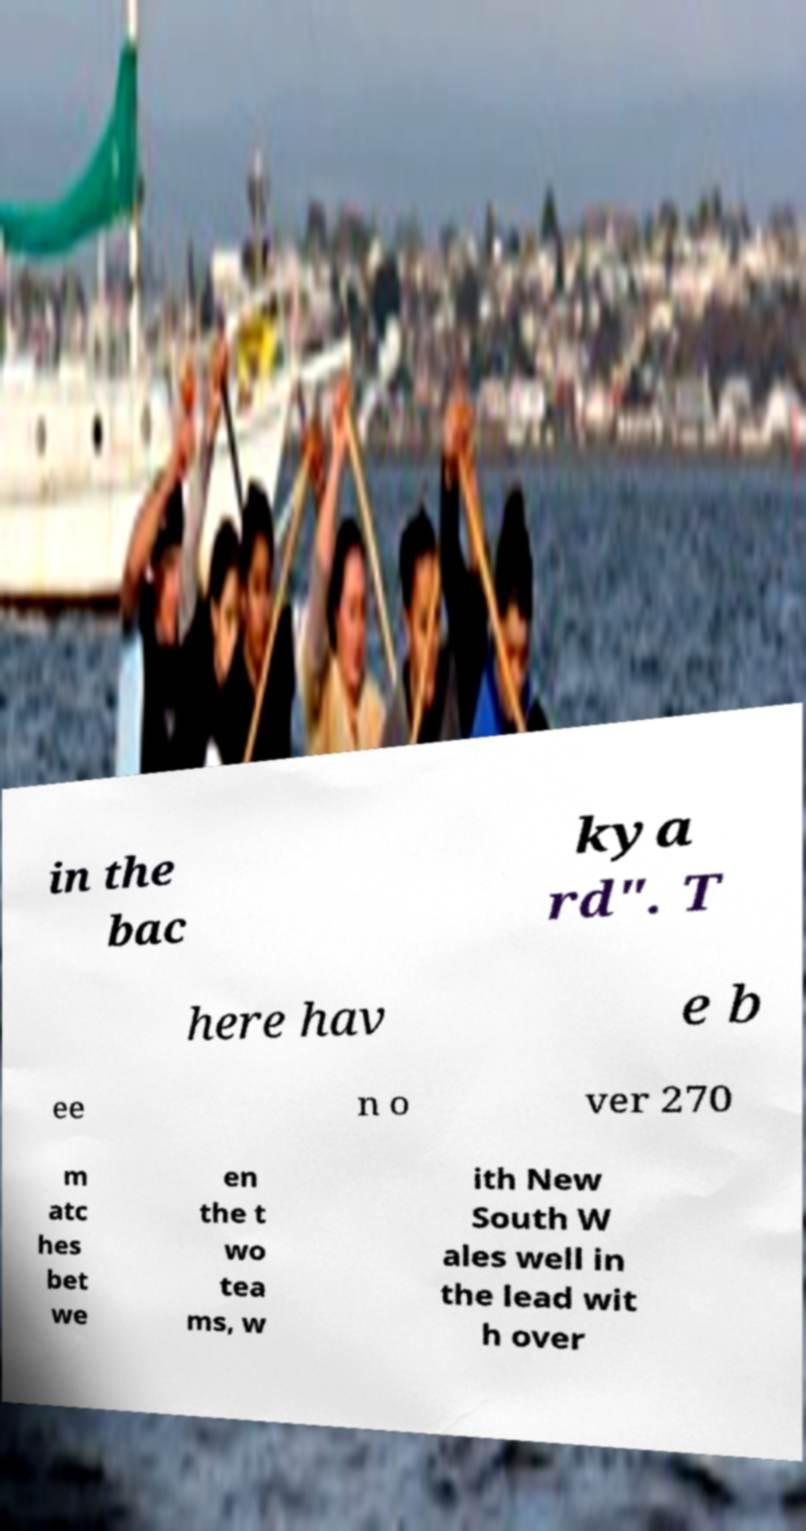Could you extract and type out the text from this image? in the bac kya rd". T here hav e b ee n o ver 270 m atc hes bet we en the t wo tea ms, w ith New South W ales well in the lead wit h over 